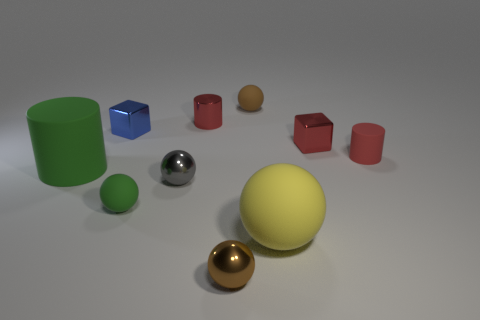Subtract all yellow balls. How many balls are left? 4 Subtract all large spheres. How many spheres are left? 4 Subtract all red spheres. Subtract all green cubes. How many spheres are left? 5 Subtract all cylinders. How many objects are left? 7 Add 8 small red matte objects. How many small red matte objects exist? 9 Subtract 0 cyan blocks. How many objects are left? 10 Subtract all small green matte blocks. Subtract all green cylinders. How many objects are left? 9 Add 5 big yellow spheres. How many big yellow spheres are left? 6 